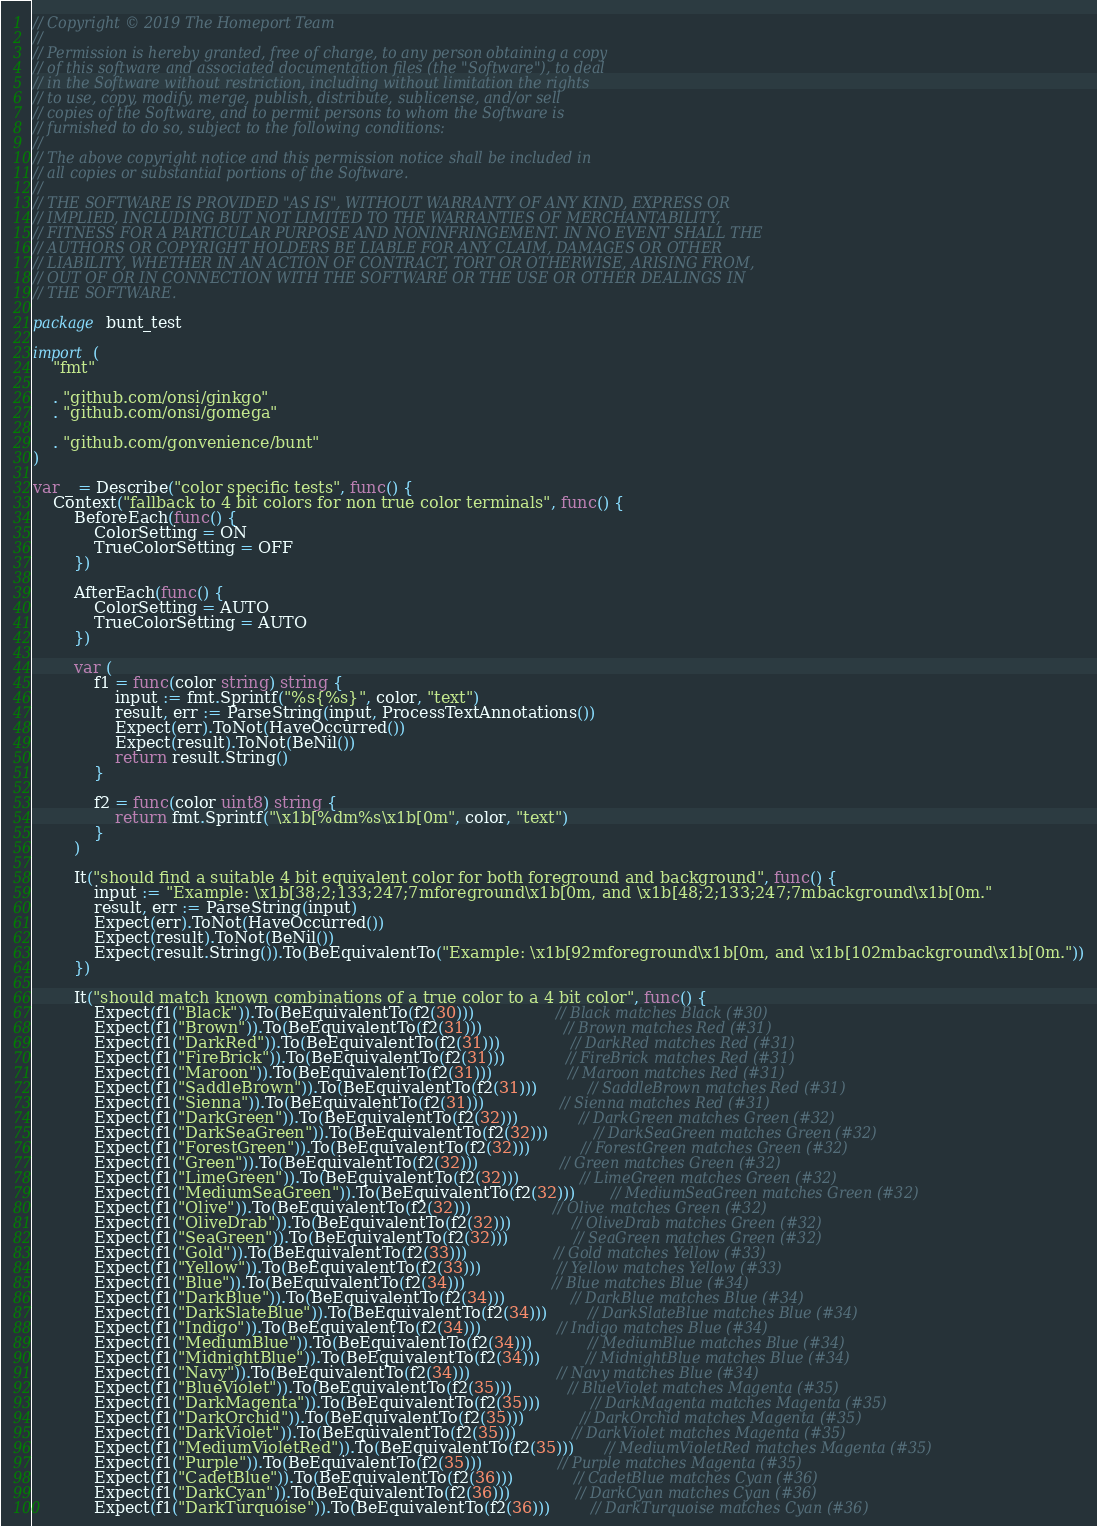Convert code to text. <code><loc_0><loc_0><loc_500><loc_500><_Go_>// Copyright © 2019 The Homeport Team
//
// Permission is hereby granted, free of charge, to any person obtaining a copy
// of this software and associated documentation files (the "Software"), to deal
// in the Software without restriction, including without limitation the rights
// to use, copy, modify, merge, publish, distribute, sublicense, and/or sell
// copies of the Software, and to permit persons to whom the Software is
// furnished to do so, subject to the following conditions:
//
// The above copyright notice and this permission notice shall be included in
// all copies or substantial portions of the Software.
//
// THE SOFTWARE IS PROVIDED "AS IS", WITHOUT WARRANTY OF ANY KIND, EXPRESS OR
// IMPLIED, INCLUDING BUT NOT LIMITED TO THE WARRANTIES OF MERCHANTABILITY,
// FITNESS FOR A PARTICULAR PURPOSE AND NONINFRINGEMENT. IN NO EVENT SHALL THE
// AUTHORS OR COPYRIGHT HOLDERS BE LIABLE FOR ANY CLAIM, DAMAGES OR OTHER
// LIABILITY, WHETHER IN AN ACTION OF CONTRACT, TORT OR OTHERWISE, ARISING FROM,
// OUT OF OR IN CONNECTION WITH THE SOFTWARE OR THE USE OR OTHER DEALINGS IN
// THE SOFTWARE.

package bunt_test

import (
	"fmt"

	. "github.com/onsi/ginkgo"
	. "github.com/onsi/gomega"

	. "github.com/gonvenience/bunt"
)

var _ = Describe("color specific tests", func() {
	Context("fallback to 4 bit colors for non true color terminals", func() {
		BeforeEach(func() {
			ColorSetting = ON
			TrueColorSetting = OFF
		})

		AfterEach(func() {
			ColorSetting = AUTO
			TrueColorSetting = AUTO
		})

		var (
			f1 = func(color string) string {
				input := fmt.Sprintf("%s{%s}", color, "text")
				result, err := ParseString(input, ProcessTextAnnotations())
				Expect(err).ToNot(HaveOccurred())
				Expect(result).ToNot(BeNil())
				return result.String()
			}

			f2 = func(color uint8) string {
				return fmt.Sprintf("\x1b[%dm%s\x1b[0m", color, "text")
			}
		)

		It("should find a suitable 4 bit equivalent color for both foreground and background", func() {
			input := "Example: \x1b[38;2;133;247;7mforeground\x1b[0m, and \x1b[48;2;133;247;7mbackground\x1b[0m."
			result, err := ParseString(input)
			Expect(err).ToNot(HaveOccurred())
			Expect(result).ToNot(BeNil())
			Expect(result.String()).To(BeEquivalentTo("Example: \x1b[92mforeground\x1b[0m, and \x1b[102mbackground\x1b[0m."))
		})

		It("should match known combinations of a true color to a 4 bit color", func() {
			Expect(f1("Black")).To(BeEquivalentTo(f2(30)))                // Black matches Black (#30)
			Expect(f1("Brown")).To(BeEquivalentTo(f2(31)))                // Brown matches Red (#31)
			Expect(f1("DarkRed")).To(BeEquivalentTo(f2(31)))              // DarkRed matches Red (#31)
			Expect(f1("FireBrick")).To(BeEquivalentTo(f2(31)))            // FireBrick matches Red (#31)
			Expect(f1("Maroon")).To(BeEquivalentTo(f2(31)))               // Maroon matches Red (#31)
			Expect(f1("SaddleBrown")).To(BeEquivalentTo(f2(31)))          // SaddleBrown matches Red (#31)
			Expect(f1("Sienna")).To(BeEquivalentTo(f2(31)))               // Sienna matches Red (#31)
			Expect(f1("DarkGreen")).To(BeEquivalentTo(f2(32)))            // DarkGreen matches Green (#32)
			Expect(f1("DarkSeaGreen")).To(BeEquivalentTo(f2(32)))         // DarkSeaGreen matches Green (#32)
			Expect(f1("ForestGreen")).To(BeEquivalentTo(f2(32)))          // ForestGreen matches Green (#32)
			Expect(f1("Green")).To(BeEquivalentTo(f2(32)))                // Green matches Green (#32)
			Expect(f1("LimeGreen")).To(BeEquivalentTo(f2(32)))            // LimeGreen matches Green (#32)
			Expect(f1("MediumSeaGreen")).To(BeEquivalentTo(f2(32)))       // MediumSeaGreen matches Green (#32)
			Expect(f1("Olive")).To(BeEquivalentTo(f2(32)))                // Olive matches Green (#32)
			Expect(f1("OliveDrab")).To(BeEquivalentTo(f2(32)))            // OliveDrab matches Green (#32)
			Expect(f1("SeaGreen")).To(BeEquivalentTo(f2(32)))             // SeaGreen matches Green (#32)
			Expect(f1("Gold")).To(BeEquivalentTo(f2(33)))                 // Gold matches Yellow (#33)
			Expect(f1("Yellow")).To(BeEquivalentTo(f2(33)))               // Yellow matches Yellow (#33)
			Expect(f1("Blue")).To(BeEquivalentTo(f2(34)))                 // Blue matches Blue (#34)
			Expect(f1("DarkBlue")).To(BeEquivalentTo(f2(34)))             // DarkBlue matches Blue (#34)
			Expect(f1("DarkSlateBlue")).To(BeEquivalentTo(f2(34)))        // DarkSlateBlue matches Blue (#34)
			Expect(f1("Indigo")).To(BeEquivalentTo(f2(34)))               // Indigo matches Blue (#34)
			Expect(f1("MediumBlue")).To(BeEquivalentTo(f2(34)))           // MediumBlue matches Blue (#34)
			Expect(f1("MidnightBlue")).To(BeEquivalentTo(f2(34)))         // MidnightBlue matches Blue (#34)
			Expect(f1("Navy")).To(BeEquivalentTo(f2(34)))                 // Navy matches Blue (#34)
			Expect(f1("BlueViolet")).To(BeEquivalentTo(f2(35)))           // BlueViolet matches Magenta (#35)
			Expect(f1("DarkMagenta")).To(BeEquivalentTo(f2(35)))          // DarkMagenta matches Magenta (#35)
			Expect(f1("DarkOrchid")).To(BeEquivalentTo(f2(35)))           // DarkOrchid matches Magenta (#35)
			Expect(f1("DarkViolet")).To(BeEquivalentTo(f2(35)))           // DarkViolet matches Magenta (#35)
			Expect(f1("MediumVioletRed")).To(BeEquivalentTo(f2(35)))      // MediumVioletRed matches Magenta (#35)
			Expect(f1("Purple")).To(BeEquivalentTo(f2(35)))               // Purple matches Magenta (#35)
			Expect(f1("CadetBlue")).To(BeEquivalentTo(f2(36)))            // CadetBlue matches Cyan (#36)
			Expect(f1("DarkCyan")).To(BeEquivalentTo(f2(36)))             // DarkCyan matches Cyan (#36)
			Expect(f1("DarkTurquoise")).To(BeEquivalentTo(f2(36)))        // DarkTurquoise matches Cyan (#36)</code> 